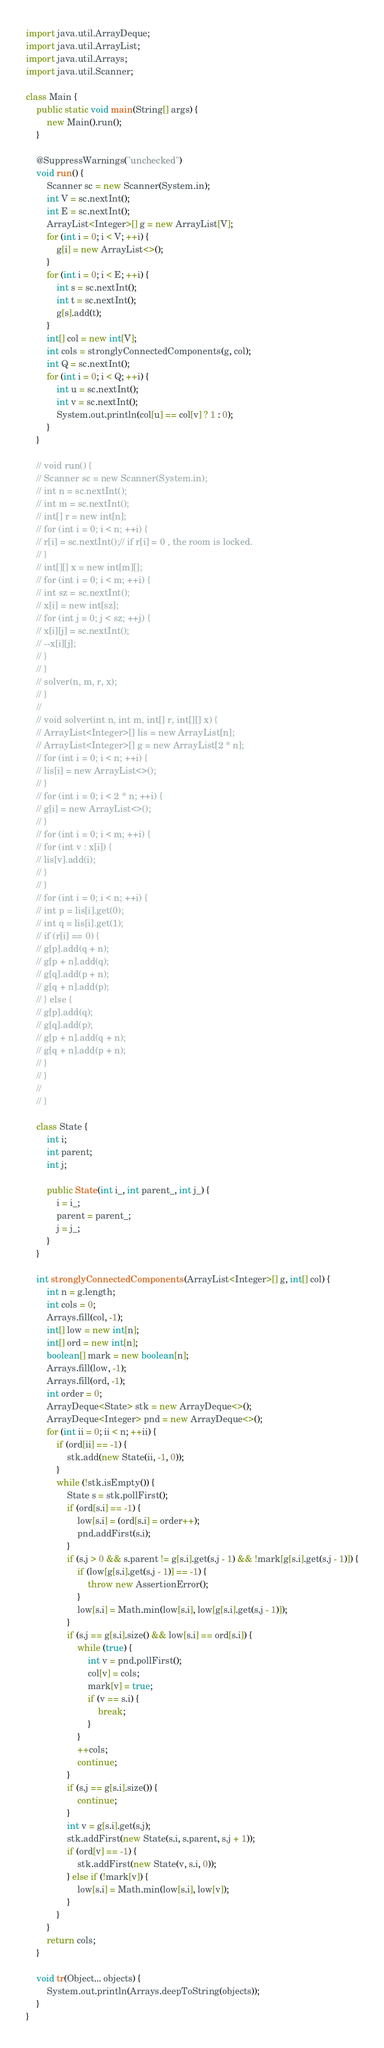Convert code to text. <code><loc_0><loc_0><loc_500><loc_500><_Java_>import java.util.ArrayDeque;
import java.util.ArrayList;
import java.util.Arrays;
import java.util.Scanner;

class Main {
	public static void main(String[] args) {
		new Main().run();
	}

	@SuppressWarnings("unchecked")
	void run() {
		Scanner sc = new Scanner(System.in);
		int V = sc.nextInt();
		int E = sc.nextInt();
		ArrayList<Integer>[] g = new ArrayList[V];
		for (int i = 0; i < V; ++i) {
			g[i] = new ArrayList<>();
		}
		for (int i = 0; i < E; ++i) {
			int s = sc.nextInt();
			int t = sc.nextInt();
			g[s].add(t);
		}
		int[] col = new int[V];
		int cols = stronglyConnectedComponents(g, col);
		int Q = sc.nextInt();
		for (int i = 0; i < Q; ++i) {
			int u = sc.nextInt();
			int v = sc.nextInt();
			System.out.println(col[u] == col[v] ? 1 : 0);
		}
	}

	// void run() {
	// Scanner sc = new Scanner(System.in);
	// int n = sc.nextInt();
	// int m = sc.nextInt();
	// int[] r = new int[n];
	// for (int i = 0; i < n; ++i) {
	// r[i] = sc.nextInt();// if r[i] = 0 , the room is locked.
	// }
	// int[][] x = new int[m][];
	// for (int i = 0; i < m; ++i) {
	// int sz = sc.nextInt();
	// x[i] = new int[sz];
	// for (int j = 0; j < sz; ++j) {
	// x[i][j] = sc.nextInt();
	// --x[i][j];
	// }
	// }
	// solver(n, m, r, x);
	// }
	//
	// void solver(int n, int m, int[] r, int[][] x) {
	// ArrayList<Integer>[] lis = new ArrayList[n];
	// ArrayList<Integer>[] g = new ArrayList[2 * n];
	// for (int i = 0; i < n; ++i) {
	// lis[i] = new ArrayList<>();
	// }
	// for (int i = 0; i < 2 * n; ++i) {
	// g[i] = new ArrayList<>();
	// }
	// for (int i = 0; i < m; ++i) {
	// for (int v : x[i]) {
	// lis[v].add(i);
	// }
	// }
	// for (int i = 0; i < n; ++i) {
	// int p = lis[i].get(0);
	// int q = lis[i].get(1);
	// if (r[i] == 0) {
	// g[p].add(q + n);
	// g[p + n].add(q);
	// g[q].add(p + n);
	// g[q + n].add(p);
	// } else {
	// g[p].add(q);
	// g[q].add(p);
	// g[p + n].add(q + n);
	// g[q + n].add(p + n);
	// }
	// }
	//
	// }

	class State {
		int i;
		int parent;
		int j;

		public State(int i_, int parent_, int j_) {
			i = i_;
			parent = parent_;
			j = j_;
		}
	}

	int stronglyConnectedComponents(ArrayList<Integer>[] g, int[] col) {
		int n = g.length;
		int cols = 0;
		Arrays.fill(col, -1);
		int[] low = new int[n];
		int[] ord = new int[n];
		boolean[] mark = new boolean[n];
		Arrays.fill(low, -1);
		Arrays.fill(ord, -1);
		int order = 0;
		ArrayDeque<State> stk = new ArrayDeque<>();
		ArrayDeque<Integer> pnd = new ArrayDeque<>();
		for (int ii = 0; ii < n; ++ii) {
			if (ord[ii] == -1) {
				stk.add(new State(ii, -1, 0));
			}
			while (!stk.isEmpty()) {
				State s = stk.pollFirst();
				if (ord[s.i] == -1) {
					low[s.i] = (ord[s.i] = order++);
					pnd.addFirst(s.i);
				}
				if (s.j > 0 && s.parent != g[s.i].get(s.j - 1) && !mark[g[s.i].get(s.j - 1)]) {
					if (low[g[s.i].get(s.j - 1)] == -1) {
						throw new AssertionError();
					}
					low[s.i] = Math.min(low[s.i], low[g[s.i].get(s.j - 1)]);
				}
				if (s.j == g[s.i].size() && low[s.i] == ord[s.i]) {
					while (true) {
						int v = pnd.pollFirst();
						col[v] = cols;
						mark[v] = true;
						if (v == s.i) {
							break;
						}
					}
					++cols;
					continue;
				}
				if (s.j == g[s.i].size()) {
					continue;
				}
				int v = g[s.i].get(s.j);
				stk.addFirst(new State(s.i, s.parent, s.j + 1));
				if (ord[v] == -1) {
					stk.addFirst(new State(v, s.i, 0));
				} else if (!mark[v]) {
					low[s.i] = Math.min(low[s.i], low[v]);
				}
			}
		}
		return cols;
	}

	void tr(Object... objects) {
		System.out.println(Arrays.deepToString(objects));
	}
}</code> 